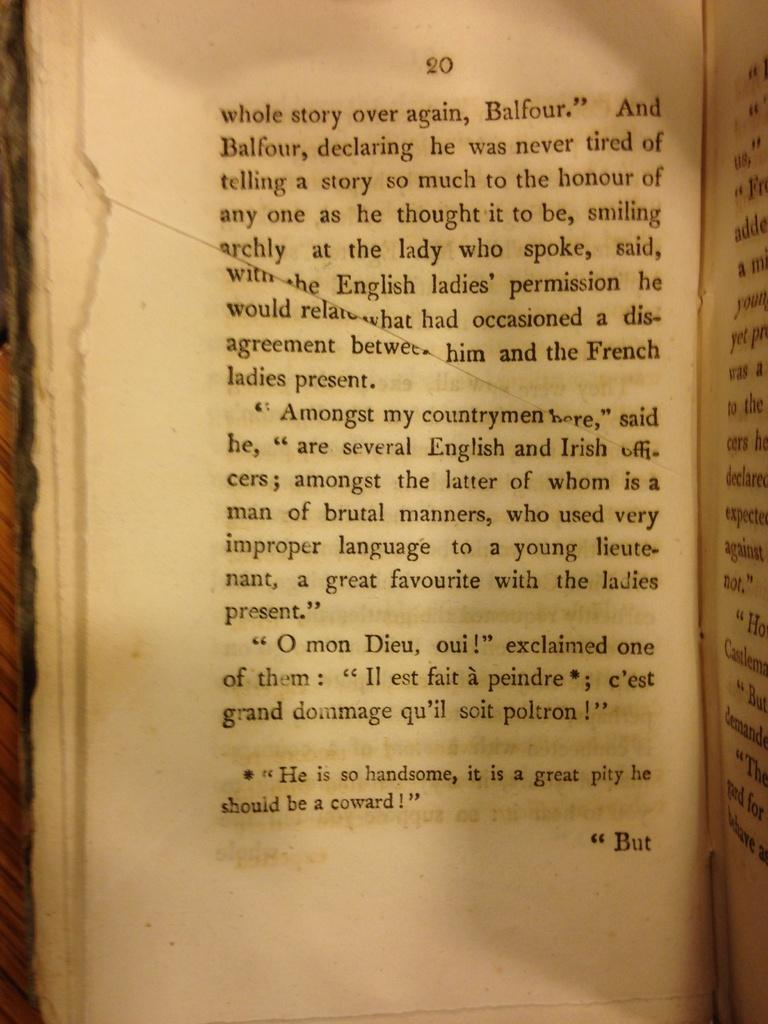<image>
Offer a succinct explanation of the picture presented. A book open to page 20 that appears to include a character named Balfour. 